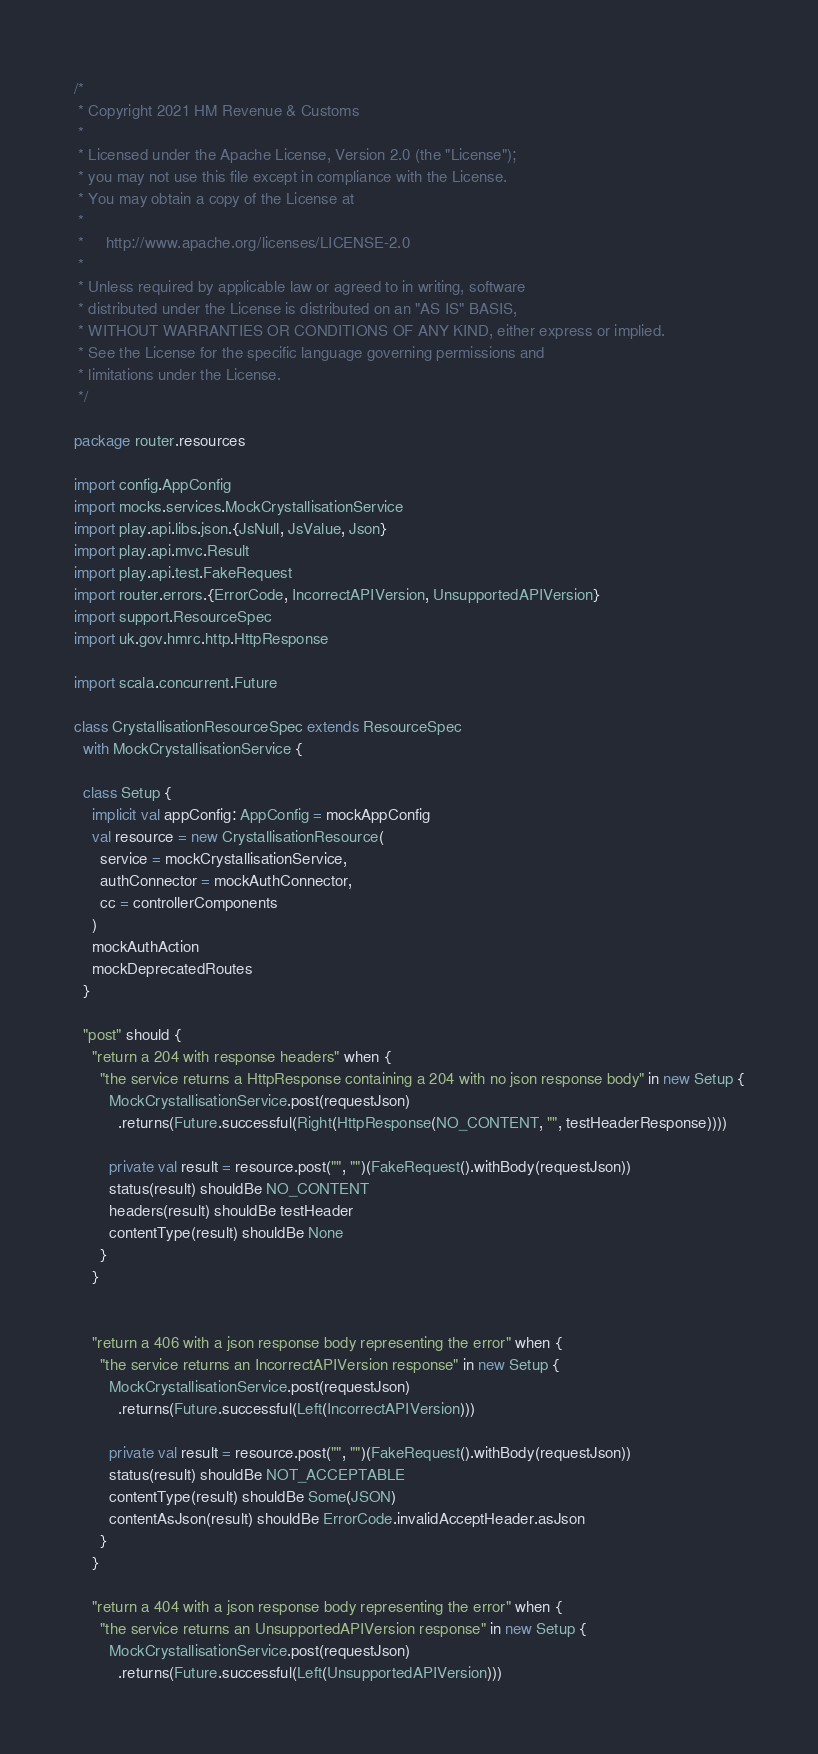Convert code to text. <code><loc_0><loc_0><loc_500><loc_500><_Scala_>/*
 * Copyright 2021 HM Revenue & Customs
 *
 * Licensed under the Apache License, Version 2.0 (the "License");
 * you may not use this file except in compliance with the License.
 * You may obtain a copy of the License at
 *
 *     http://www.apache.org/licenses/LICENSE-2.0
 *
 * Unless required by applicable law or agreed to in writing, software
 * distributed under the License is distributed on an "AS IS" BASIS,
 * WITHOUT WARRANTIES OR CONDITIONS OF ANY KIND, either express or implied.
 * See the License for the specific language governing permissions and
 * limitations under the License.
 */

package router.resources

import config.AppConfig
import mocks.services.MockCrystallisationService
import play.api.libs.json.{JsNull, JsValue, Json}
import play.api.mvc.Result
import play.api.test.FakeRequest
import router.errors.{ErrorCode, IncorrectAPIVersion, UnsupportedAPIVersion}
import support.ResourceSpec
import uk.gov.hmrc.http.HttpResponse

import scala.concurrent.Future

class CrystallisationResourceSpec extends ResourceSpec
  with MockCrystallisationService {

  class Setup {
    implicit val appConfig: AppConfig = mockAppConfig
    val resource = new CrystallisationResource(
      service = mockCrystallisationService,
      authConnector = mockAuthConnector,
      cc = controllerComponents
    )
    mockAuthAction
    mockDeprecatedRoutes
  }

  "post" should {
    "return a 204 with response headers" when {
      "the service returns a HttpResponse containing a 204 with no json response body" in new Setup {
        MockCrystallisationService.post(requestJson)
          .returns(Future.successful(Right(HttpResponse(NO_CONTENT, "", testHeaderResponse))))

        private val result = resource.post("", "")(FakeRequest().withBody(requestJson))
        status(result) shouldBe NO_CONTENT
        headers(result) shouldBe testHeader
        contentType(result) shouldBe None
      }
    }


    "return a 406 with a json response body representing the error" when {
      "the service returns an IncorrectAPIVersion response" in new Setup {
        MockCrystallisationService.post(requestJson)
          .returns(Future.successful(Left(IncorrectAPIVersion)))

        private val result = resource.post("", "")(FakeRequest().withBody(requestJson))
        status(result) shouldBe NOT_ACCEPTABLE
        contentType(result) shouldBe Some(JSON)
        contentAsJson(result) shouldBe ErrorCode.invalidAcceptHeader.asJson
      }
    }

    "return a 404 with a json response body representing the error" when {
      "the service returns an UnsupportedAPIVersion response" in new Setup {
        MockCrystallisationService.post(requestJson)
          .returns(Future.successful(Left(UnsupportedAPIVersion)))
</code> 